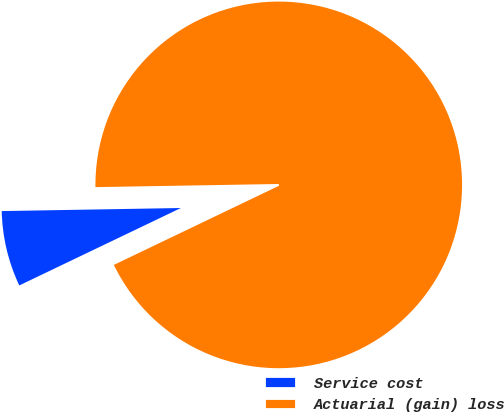<chart> <loc_0><loc_0><loc_500><loc_500><pie_chart><fcel>Service cost<fcel>Actuarial (gain) loss<nl><fcel>6.84%<fcel>93.16%<nl></chart> 